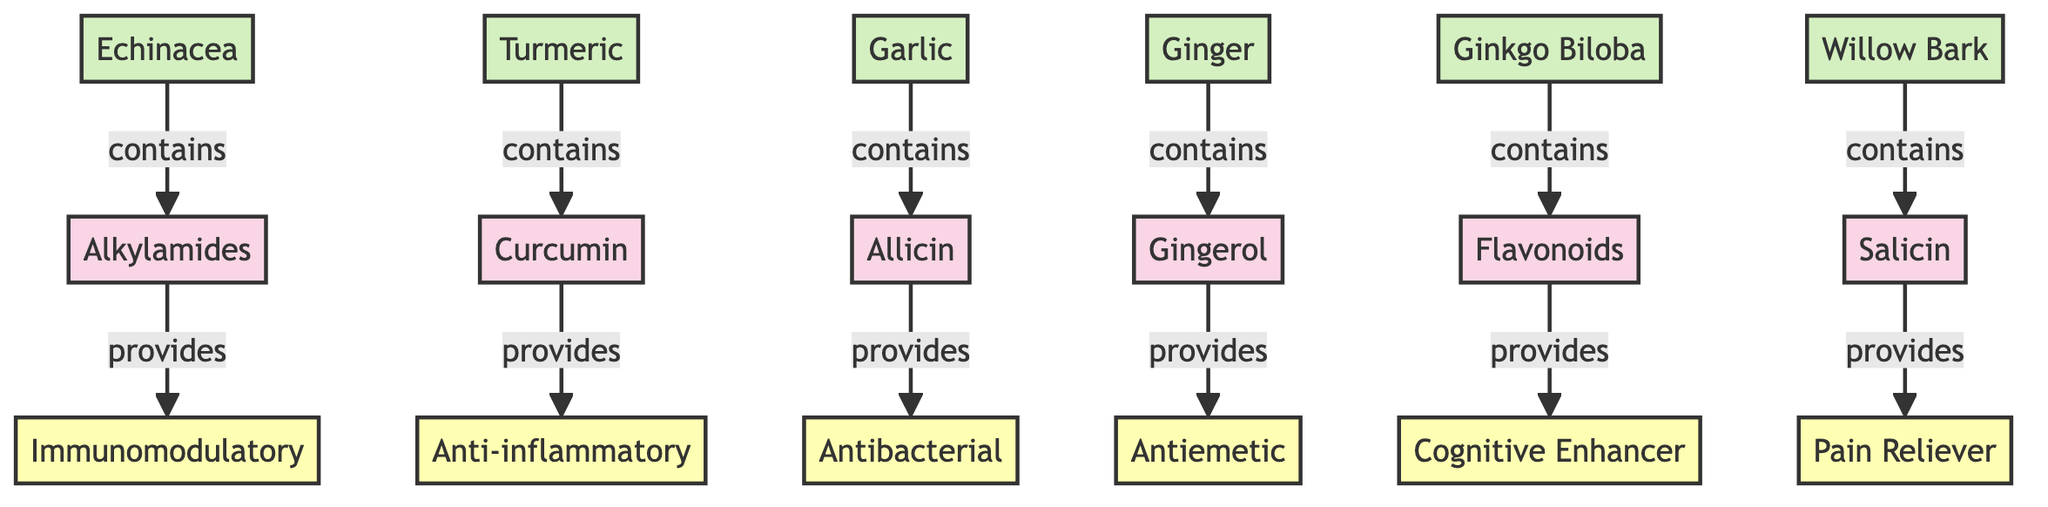What plant contains Alkylamides? The diagram shows a directed edge from the node labeled "Echinacea" to "Alkylamides," indicating that Echinacea contains Alkylamides.
Answer: Echinacea What is the health benefit provided by Curcumin? Following the directed edge from "Curcumin" to "Anti-inflammatory," it is clear that Curcumin provides the health benefit of being anti-inflammatory.
Answer: Anti-inflammatory How many plants are illustrated in the diagram? By counting the plant nodes (Echinacea, Turmeric, Garlic, Ginger, Ginkgo Biloba, and Willow Bark), we find there are a total of 6 plant nodes in the diagram.
Answer: 6 What compound is associated with Ginger? There is a directed edge from "Ginger" to "Gingerol," indicating that Ginger is associated with the compound Gingerol.
Answer: Gingerol Which health benefit is linked to Allicin? The pathway shows that Allicin is connected to "Antibacterial," meaning Allicin provides the health benefit of antibacterial properties.
Answer: Antibacterial What type of compounds do Ginkgo Biloba contain? The arrow from "Ginkgo Biloba" to "Flavonoids" indicates that Ginkgo Biloba contains flavonoids as its medicinal compounds.
Answer: Flavonoids Which plant is linked to Pain Reliever? Analyzing the connection, "Willow Bark" points to "Salicin," which in turn points to "Pain Reliever," showing that Willow Bark is linked to this health benefit.
Answer: Willow Bark What are the connections for Gingerol? Gingerol receives connections from two nodes; it is linked to "Ginger," which contains it, and it provides the health benefit of "Antiemetic."
Answer: Ginger, Antiemetic Which compound provides Cognitive Enhancer? The diagram indicates that "Flavonoids," contained within "Ginkgo Biloba," provides the health benefit labeled as Cognitive Enhancer.
Answer: Flavonoids 